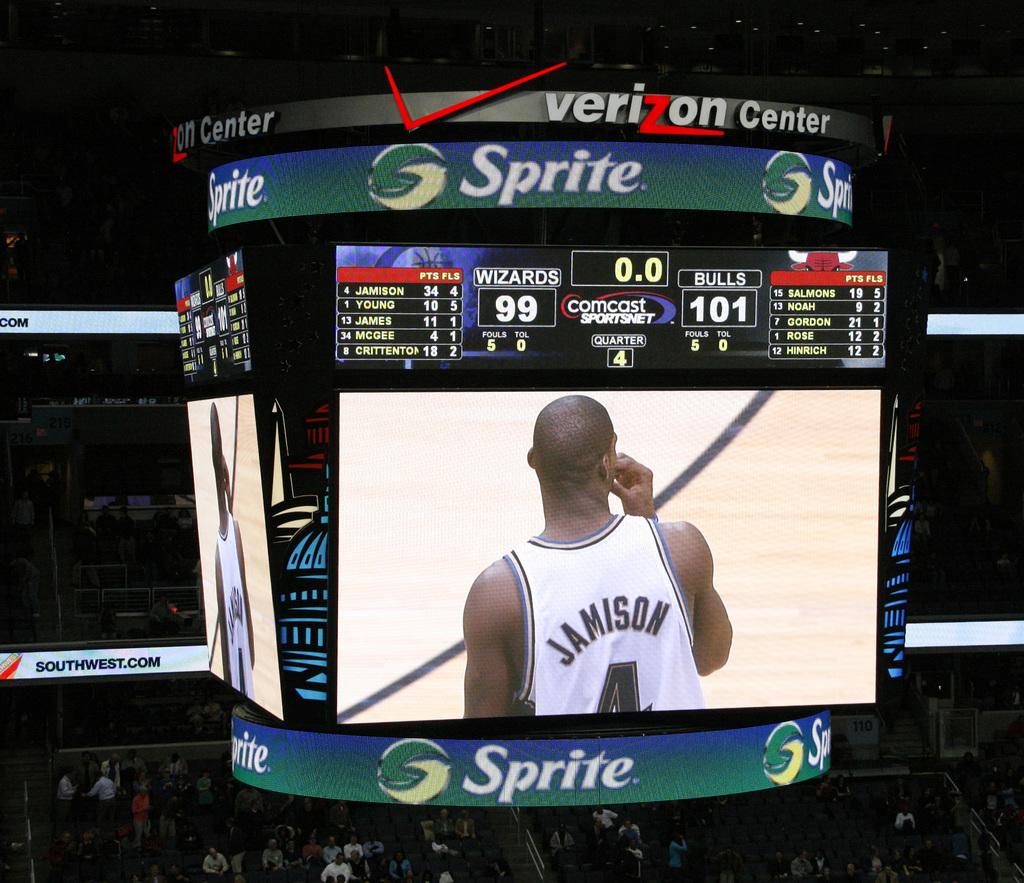What is the name of player shown on sign?
Provide a succinct answer. Jamison. 